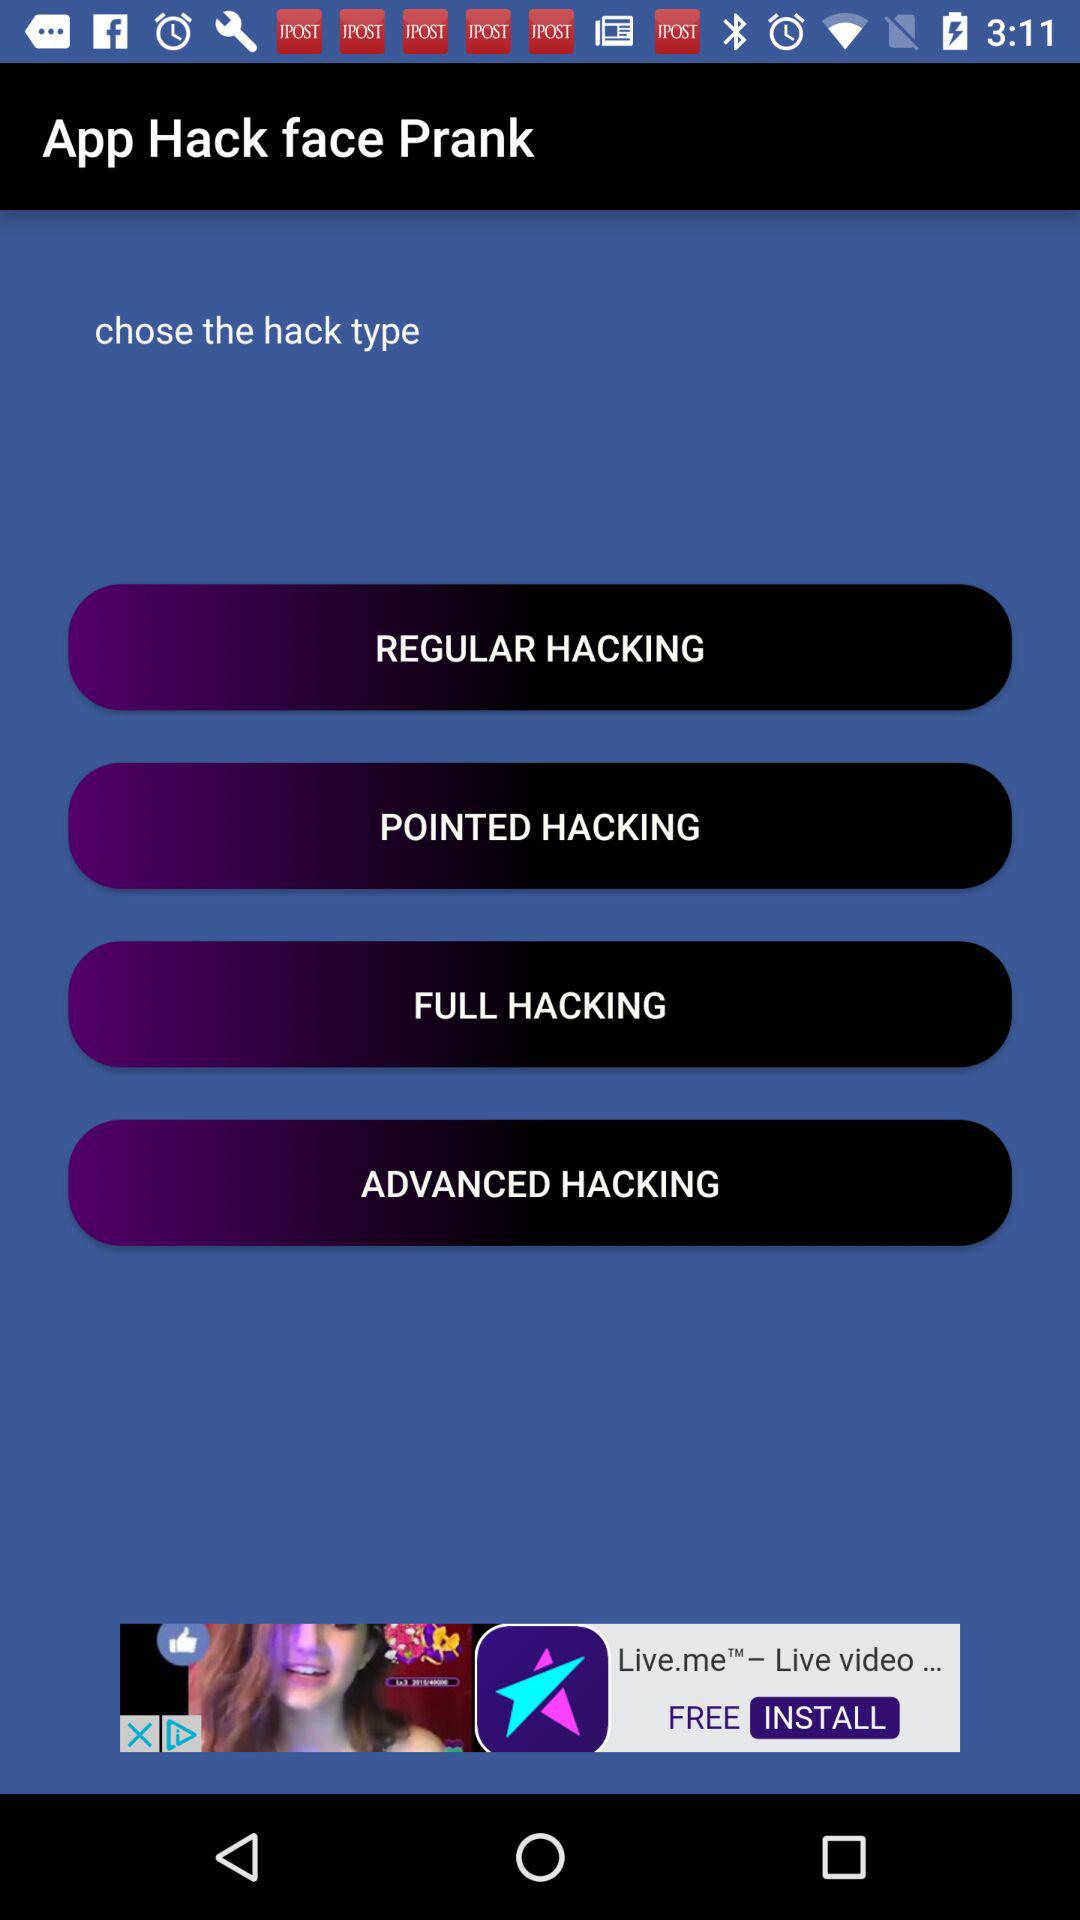What are the hacking options? The hacking options are "REGULAR HACKING", "POINTED HACKING", "FULL HACKING" and "ADVANCED HACKING". 